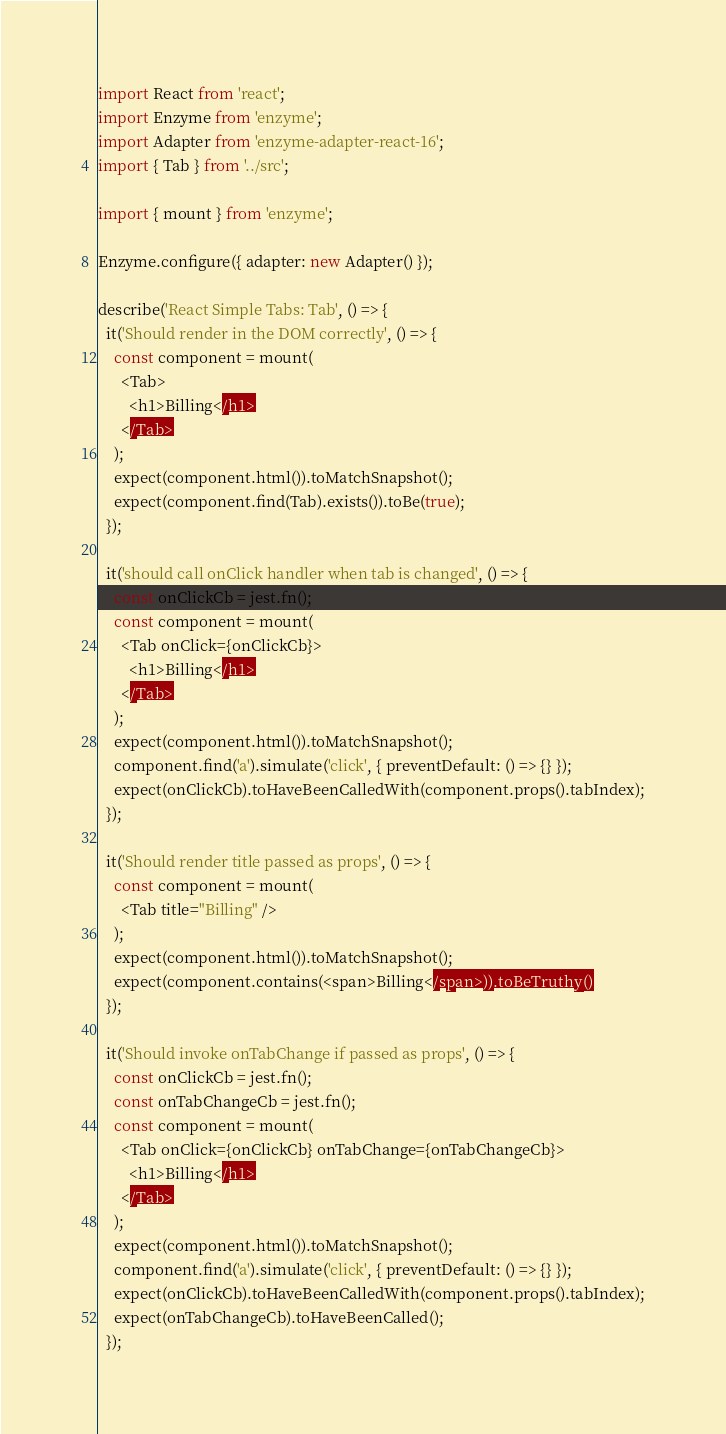Convert code to text. <code><loc_0><loc_0><loc_500><loc_500><_JavaScript_>import React from 'react';
import Enzyme from 'enzyme';
import Adapter from 'enzyme-adapter-react-16';
import { Tab } from '../src';

import { mount } from 'enzyme';

Enzyme.configure({ adapter: new Adapter() });

describe('React Simple Tabs: Tab', () => {
  it('Should render in the DOM correctly', () => {
    const component = mount(
      <Tab>
        <h1>Billing</h1>
      </Tab>
    );
    expect(component.html()).toMatchSnapshot();
    expect(component.find(Tab).exists()).toBe(true);
  });

  it('should call onClick handler when tab is changed', () => {
    const onClickCb = jest.fn();
    const component = mount(
      <Tab onClick={onClickCb}>
        <h1>Billing</h1>
      </Tab>
    );
    expect(component.html()).toMatchSnapshot();
    component.find('a').simulate('click', { preventDefault: () => {} });
    expect(onClickCb).toHaveBeenCalledWith(component.props().tabIndex);
  });

  it('Should render title passed as props', () => {
    const component = mount(
      <Tab title="Billing" />
    );
    expect(component.html()).toMatchSnapshot();
    expect(component.contains(<span>Billing</span>)).toBeTruthy()
  });

  it('Should invoke onTabChange if passed as props', () => {
    const onClickCb = jest.fn();
    const onTabChangeCb = jest.fn();
    const component = mount(
      <Tab onClick={onClickCb} onTabChange={onTabChangeCb}>
        <h1>Billing</h1>
      </Tab>
    );
    expect(component.html()).toMatchSnapshot();
    component.find('a').simulate('click', { preventDefault: () => {} });
    expect(onClickCb).toHaveBeenCalledWith(component.props().tabIndex);
    expect(onTabChangeCb).toHaveBeenCalled();
  });
</code> 